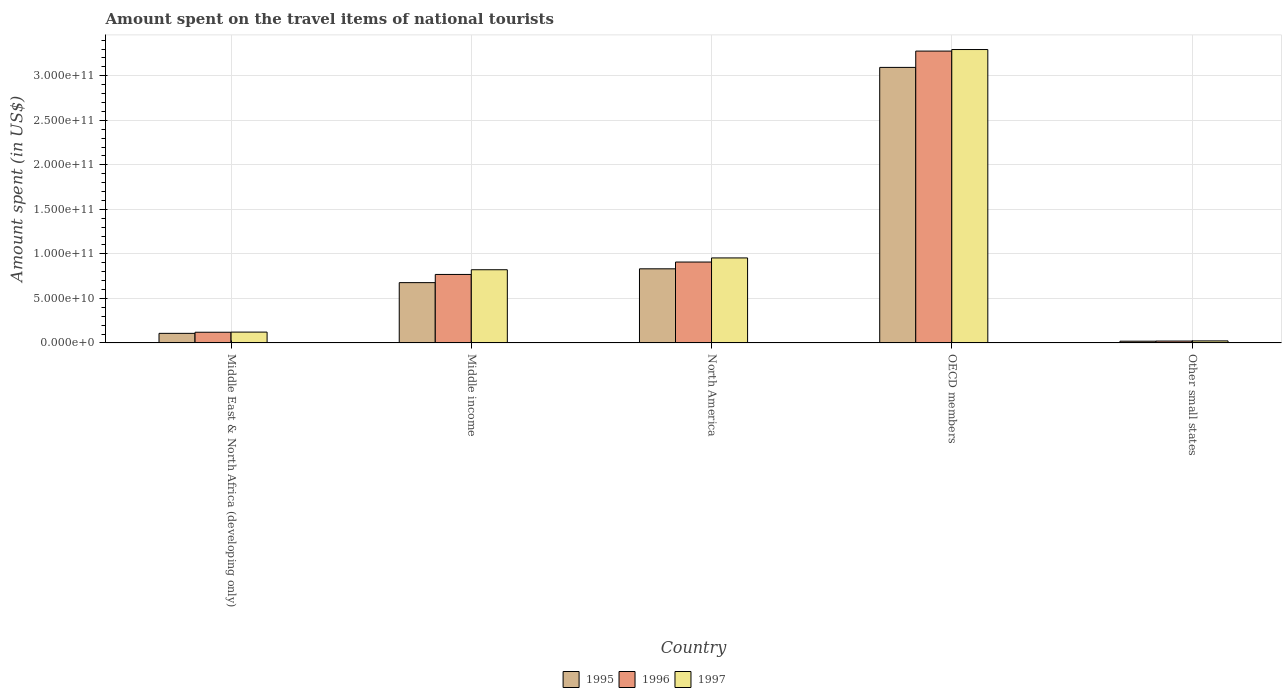Are the number of bars per tick equal to the number of legend labels?
Give a very brief answer. Yes. How many bars are there on the 1st tick from the left?
Provide a succinct answer. 3. What is the label of the 1st group of bars from the left?
Your answer should be compact. Middle East & North Africa (developing only). In how many cases, is the number of bars for a given country not equal to the number of legend labels?
Provide a succinct answer. 0. What is the amount spent on the travel items of national tourists in 1997 in North America?
Make the answer very short. 9.55e+1. Across all countries, what is the maximum amount spent on the travel items of national tourists in 1997?
Your answer should be very brief. 3.29e+11. Across all countries, what is the minimum amount spent on the travel items of national tourists in 1996?
Ensure brevity in your answer.  2.12e+09. In which country was the amount spent on the travel items of national tourists in 1997 minimum?
Keep it short and to the point. Other small states. What is the total amount spent on the travel items of national tourists in 1996 in the graph?
Provide a short and direct response. 5.10e+11. What is the difference between the amount spent on the travel items of national tourists in 1995 in North America and that in OECD members?
Your answer should be very brief. -2.26e+11. What is the difference between the amount spent on the travel items of national tourists in 1995 in OECD members and the amount spent on the travel items of national tourists in 1996 in North America?
Make the answer very short. 2.19e+11. What is the average amount spent on the travel items of national tourists in 1997 per country?
Offer a terse response. 1.04e+11. What is the difference between the amount spent on the travel items of national tourists of/in 1996 and amount spent on the travel items of national tourists of/in 1995 in Other small states?
Provide a succinct answer. 1.64e+08. In how many countries, is the amount spent on the travel items of national tourists in 1995 greater than 170000000000 US$?
Provide a short and direct response. 1. What is the ratio of the amount spent on the travel items of national tourists in 1996 in Middle East & North Africa (developing only) to that in North America?
Offer a terse response. 0.13. Is the amount spent on the travel items of national tourists in 1995 in OECD members less than that in Other small states?
Your answer should be very brief. No. What is the difference between the highest and the second highest amount spent on the travel items of national tourists in 1996?
Your answer should be compact. 2.51e+11. What is the difference between the highest and the lowest amount spent on the travel items of national tourists in 1996?
Your response must be concise. 3.26e+11. In how many countries, is the amount spent on the travel items of national tourists in 1996 greater than the average amount spent on the travel items of national tourists in 1996 taken over all countries?
Your answer should be compact. 1. What does the 2nd bar from the left in OECD members represents?
Offer a very short reply. 1996. How many bars are there?
Keep it short and to the point. 15. How many countries are there in the graph?
Your answer should be very brief. 5. Are the values on the major ticks of Y-axis written in scientific E-notation?
Offer a very short reply. Yes. Does the graph contain any zero values?
Keep it short and to the point. No. Does the graph contain grids?
Give a very brief answer. Yes. Where does the legend appear in the graph?
Ensure brevity in your answer.  Bottom center. How are the legend labels stacked?
Offer a very short reply. Horizontal. What is the title of the graph?
Give a very brief answer. Amount spent on the travel items of national tourists. Does "1992" appear as one of the legend labels in the graph?
Your answer should be compact. No. What is the label or title of the Y-axis?
Your response must be concise. Amount spent (in US$). What is the Amount spent (in US$) of 1995 in Middle East & North Africa (developing only)?
Give a very brief answer. 1.08e+1. What is the Amount spent (in US$) in 1996 in Middle East & North Africa (developing only)?
Make the answer very short. 1.20e+1. What is the Amount spent (in US$) in 1997 in Middle East & North Africa (developing only)?
Your answer should be compact. 1.22e+1. What is the Amount spent (in US$) of 1995 in Middle income?
Offer a very short reply. 6.77e+1. What is the Amount spent (in US$) of 1996 in Middle income?
Make the answer very short. 7.69e+1. What is the Amount spent (in US$) of 1997 in Middle income?
Provide a short and direct response. 8.22e+1. What is the Amount spent (in US$) in 1995 in North America?
Give a very brief answer. 8.32e+1. What is the Amount spent (in US$) of 1996 in North America?
Your answer should be compact. 9.09e+1. What is the Amount spent (in US$) in 1997 in North America?
Offer a terse response. 9.55e+1. What is the Amount spent (in US$) of 1995 in OECD members?
Provide a succinct answer. 3.09e+11. What is the Amount spent (in US$) in 1996 in OECD members?
Keep it short and to the point. 3.28e+11. What is the Amount spent (in US$) in 1997 in OECD members?
Make the answer very short. 3.29e+11. What is the Amount spent (in US$) of 1995 in Other small states?
Keep it short and to the point. 1.95e+09. What is the Amount spent (in US$) in 1996 in Other small states?
Make the answer very short. 2.12e+09. What is the Amount spent (in US$) in 1997 in Other small states?
Your answer should be compact. 2.29e+09. Across all countries, what is the maximum Amount spent (in US$) of 1995?
Keep it short and to the point. 3.09e+11. Across all countries, what is the maximum Amount spent (in US$) in 1996?
Provide a succinct answer. 3.28e+11. Across all countries, what is the maximum Amount spent (in US$) of 1997?
Make the answer very short. 3.29e+11. Across all countries, what is the minimum Amount spent (in US$) in 1995?
Ensure brevity in your answer.  1.95e+09. Across all countries, what is the minimum Amount spent (in US$) in 1996?
Offer a very short reply. 2.12e+09. Across all countries, what is the minimum Amount spent (in US$) in 1997?
Your response must be concise. 2.29e+09. What is the total Amount spent (in US$) of 1995 in the graph?
Your answer should be very brief. 4.73e+11. What is the total Amount spent (in US$) in 1996 in the graph?
Keep it short and to the point. 5.10e+11. What is the total Amount spent (in US$) of 1997 in the graph?
Make the answer very short. 5.22e+11. What is the difference between the Amount spent (in US$) in 1995 in Middle East & North Africa (developing only) and that in Middle income?
Keep it short and to the point. -5.69e+1. What is the difference between the Amount spent (in US$) of 1996 in Middle East & North Africa (developing only) and that in Middle income?
Offer a very short reply. -6.49e+1. What is the difference between the Amount spent (in US$) of 1997 in Middle East & North Africa (developing only) and that in Middle income?
Your answer should be compact. -7.00e+1. What is the difference between the Amount spent (in US$) in 1995 in Middle East & North Africa (developing only) and that in North America?
Your answer should be compact. -7.25e+1. What is the difference between the Amount spent (in US$) of 1996 in Middle East & North Africa (developing only) and that in North America?
Provide a short and direct response. -7.88e+1. What is the difference between the Amount spent (in US$) in 1997 in Middle East & North Africa (developing only) and that in North America?
Make the answer very short. -8.33e+1. What is the difference between the Amount spent (in US$) in 1995 in Middle East & North Africa (developing only) and that in OECD members?
Your answer should be compact. -2.99e+11. What is the difference between the Amount spent (in US$) in 1996 in Middle East & North Africa (developing only) and that in OECD members?
Offer a terse response. -3.16e+11. What is the difference between the Amount spent (in US$) in 1997 in Middle East & North Africa (developing only) and that in OECD members?
Your answer should be very brief. -3.17e+11. What is the difference between the Amount spent (in US$) of 1995 in Middle East & North Africa (developing only) and that in Other small states?
Your answer should be compact. 8.82e+09. What is the difference between the Amount spent (in US$) of 1996 in Middle East & North Africa (developing only) and that in Other small states?
Ensure brevity in your answer.  9.89e+09. What is the difference between the Amount spent (in US$) of 1997 in Middle East & North Africa (developing only) and that in Other small states?
Your response must be concise. 9.88e+09. What is the difference between the Amount spent (in US$) in 1995 in Middle income and that in North America?
Give a very brief answer. -1.55e+1. What is the difference between the Amount spent (in US$) of 1996 in Middle income and that in North America?
Provide a short and direct response. -1.39e+1. What is the difference between the Amount spent (in US$) of 1997 in Middle income and that in North America?
Your answer should be compact. -1.33e+1. What is the difference between the Amount spent (in US$) in 1995 in Middle income and that in OECD members?
Make the answer very short. -2.42e+11. What is the difference between the Amount spent (in US$) of 1996 in Middle income and that in OECD members?
Offer a very short reply. -2.51e+11. What is the difference between the Amount spent (in US$) in 1997 in Middle income and that in OECD members?
Ensure brevity in your answer.  -2.47e+11. What is the difference between the Amount spent (in US$) of 1995 in Middle income and that in Other small states?
Your answer should be compact. 6.58e+1. What is the difference between the Amount spent (in US$) of 1996 in Middle income and that in Other small states?
Make the answer very short. 7.48e+1. What is the difference between the Amount spent (in US$) in 1997 in Middle income and that in Other small states?
Make the answer very short. 7.99e+1. What is the difference between the Amount spent (in US$) in 1995 in North America and that in OECD members?
Keep it short and to the point. -2.26e+11. What is the difference between the Amount spent (in US$) in 1996 in North America and that in OECD members?
Keep it short and to the point. -2.37e+11. What is the difference between the Amount spent (in US$) in 1997 in North America and that in OECD members?
Your answer should be compact. -2.34e+11. What is the difference between the Amount spent (in US$) of 1995 in North America and that in Other small states?
Your answer should be compact. 8.13e+1. What is the difference between the Amount spent (in US$) of 1996 in North America and that in Other small states?
Keep it short and to the point. 8.87e+1. What is the difference between the Amount spent (in US$) in 1997 in North America and that in Other small states?
Keep it short and to the point. 9.32e+1. What is the difference between the Amount spent (in US$) of 1995 in OECD members and that in Other small states?
Keep it short and to the point. 3.07e+11. What is the difference between the Amount spent (in US$) in 1996 in OECD members and that in Other small states?
Give a very brief answer. 3.26e+11. What is the difference between the Amount spent (in US$) in 1997 in OECD members and that in Other small states?
Your response must be concise. 3.27e+11. What is the difference between the Amount spent (in US$) of 1995 in Middle East & North Africa (developing only) and the Amount spent (in US$) of 1996 in Middle income?
Your answer should be compact. -6.61e+1. What is the difference between the Amount spent (in US$) in 1995 in Middle East & North Africa (developing only) and the Amount spent (in US$) in 1997 in Middle income?
Your answer should be compact. -7.14e+1. What is the difference between the Amount spent (in US$) of 1996 in Middle East & North Africa (developing only) and the Amount spent (in US$) of 1997 in Middle income?
Provide a succinct answer. -7.02e+1. What is the difference between the Amount spent (in US$) in 1995 in Middle East & North Africa (developing only) and the Amount spent (in US$) in 1996 in North America?
Your answer should be very brief. -8.01e+1. What is the difference between the Amount spent (in US$) in 1995 in Middle East & North Africa (developing only) and the Amount spent (in US$) in 1997 in North America?
Offer a terse response. -8.47e+1. What is the difference between the Amount spent (in US$) of 1996 in Middle East & North Africa (developing only) and the Amount spent (in US$) of 1997 in North America?
Give a very brief answer. -8.35e+1. What is the difference between the Amount spent (in US$) in 1995 in Middle East & North Africa (developing only) and the Amount spent (in US$) in 1996 in OECD members?
Keep it short and to the point. -3.17e+11. What is the difference between the Amount spent (in US$) of 1995 in Middle East & North Africa (developing only) and the Amount spent (in US$) of 1997 in OECD members?
Keep it short and to the point. -3.19e+11. What is the difference between the Amount spent (in US$) in 1996 in Middle East & North Africa (developing only) and the Amount spent (in US$) in 1997 in OECD members?
Your answer should be very brief. -3.17e+11. What is the difference between the Amount spent (in US$) of 1995 in Middle East & North Africa (developing only) and the Amount spent (in US$) of 1996 in Other small states?
Make the answer very short. 8.65e+09. What is the difference between the Amount spent (in US$) in 1995 in Middle East & North Africa (developing only) and the Amount spent (in US$) in 1997 in Other small states?
Provide a succinct answer. 8.48e+09. What is the difference between the Amount spent (in US$) of 1996 in Middle East & North Africa (developing only) and the Amount spent (in US$) of 1997 in Other small states?
Provide a succinct answer. 9.72e+09. What is the difference between the Amount spent (in US$) of 1995 in Middle income and the Amount spent (in US$) of 1996 in North America?
Keep it short and to the point. -2.31e+1. What is the difference between the Amount spent (in US$) of 1995 in Middle income and the Amount spent (in US$) of 1997 in North America?
Make the answer very short. -2.78e+1. What is the difference between the Amount spent (in US$) in 1996 in Middle income and the Amount spent (in US$) in 1997 in North America?
Your answer should be very brief. -1.86e+1. What is the difference between the Amount spent (in US$) of 1995 in Middle income and the Amount spent (in US$) of 1996 in OECD members?
Keep it short and to the point. -2.60e+11. What is the difference between the Amount spent (in US$) in 1995 in Middle income and the Amount spent (in US$) in 1997 in OECD members?
Make the answer very short. -2.62e+11. What is the difference between the Amount spent (in US$) of 1996 in Middle income and the Amount spent (in US$) of 1997 in OECD members?
Your response must be concise. -2.53e+11. What is the difference between the Amount spent (in US$) in 1995 in Middle income and the Amount spent (in US$) in 1996 in Other small states?
Provide a succinct answer. 6.56e+1. What is the difference between the Amount spent (in US$) of 1995 in Middle income and the Amount spent (in US$) of 1997 in Other small states?
Your answer should be compact. 6.54e+1. What is the difference between the Amount spent (in US$) of 1996 in Middle income and the Amount spent (in US$) of 1997 in Other small states?
Provide a succinct answer. 7.46e+1. What is the difference between the Amount spent (in US$) in 1995 in North America and the Amount spent (in US$) in 1996 in OECD members?
Your answer should be very brief. -2.45e+11. What is the difference between the Amount spent (in US$) of 1995 in North America and the Amount spent (in US$) of 1997 in OECD members?
Your answer should be compact. -2.46e+11. What is the difference between the Amount spent (in US$) of 1996 in North America and the Amount spent (in US$) of 1997 in OECD members?
Your response must be concise. -2.39e+11. What is the difference between the Amount spent (in US$) in 1995 in North America and the Amount spent (in US$) in 1996 in Other small states?
Keep it short and to the point. 8.11e+1. What is the difference between the Amount spent (in US$) in 1995 in North America and the Amount spent (in US$) in 1997 in Other small states?
Provide a short and direct response. 8.10e+1. What is the difference between the Amount spent (in US$) of 1996 in North America and the Amount spent (in US$) of 1997 in Other small states?
Give a very brief answer. 8.86e+1. What is the difference between the Amount spent (in US$) of 1995 in OECD members and the Amount spent (in US$) of 1996 in Other small states?
Make the answer very short. 3.07e+11. What is the difference between the Amount spent (in US$) of 1995 in OECD members and the Amount spent (in US$) of 1997 in Other small states?
Make the answer very short. 3.07e+11. What is the difference between the Amount spent (in US$) of 1996 in OECD members and the Amount spent (in US$) of 1997 in Other small states?
Give a very brief answer. 3.25e+11. What is the average Amount spent (in US$) in 1995 per country?
Your response must be concise. 9.46e+1. What is the average Amount spent (in US$) of 1996 per country?
Ensure brevity in your answer.  1.02e+11. What is the average Amount spent (in US$) in 1997 per country?
Your response must be concise. 1.04e+11. What is the difference between the Amount spent (in US$) of 1995 and Amount spent (in US$) of 1996 in Middle East & North Africa (developing only)?
Make the answer very short. -1.24e+09. What is the difference between the Amount spent (in US$) in 1995 and Amount spent (in US$) in 1997 in Middle East & North Africa (developing only)?
Offer a very short reply. -1.40e+09. What is the difference between the Amount spent (in US$) in 1996 and Amount spent (in US$) in 1997 in Middle East & North Africa (developing only)?
Your response must be concise. -1.61e+08. What is the difference between the Amount spent (in US$) of 1995 and Amount spent (in US$) of 1996 in Middle income?
Your answer should be very brief. -9.19e+09. What is the difference between the Amount spent (in US$) in 1995 and Amount spent (in US$) in 1997 in Middle income?
Your answer should be very brief. -1.45e+1. What is the difference between the Amount spent (in US$) in 1996 and Amount spent (in US$) in 1997 in Middle income?
Keep it short and to the point. -5.28e+09. What is the difference between the Amount spent (in US$) of 1995 and Amount spent (in US$) of 1996 in North America?
Keep it short and to the point. -7.61e+09. What is the difference between the Amount spent (in US$) in 1995 and Amount spent (in US$) in 1997 in North America?
Your response must be concise. -1.22e+1. What is the difference between the Amount spent (in US$) in 1996 and Amount spent (in US$) in 1997 in North America?
Your response must be concise. -4.62e+09. What is the difference between the Amount spent (in US$) in 1995 and Amount spent (in US$) in 1996 in OECD members?
Make the answer very short. -1.83e+1. What is the difference between the Amount spent (in US$) of 1995 and Amount spent (in US$) of 1997 in OECD members?
Your answer should be compact. -2.01e+1. What is the difference between the Amount spent (in US$) of 1996 and Amount spent (in US$) of 1997 in OECD members?
Provide a short and direct response. -1.72e+09. What is the difference between the Amount spent (in US$) in 1995 and Amount spent (in US$) in 1996 in Other small states?
Offer a very short reply. -1.64e+08. What is the difference between the Amount spent (in US$) in 1995 and Amount spent (in US$) in 1997 in Other small states?
Provide a succinct answer. -3.34e+08. What is the difference between the Amount spent (in US$) of 1996 and Amount spent (in US$) of 1997 in Other small states?
Make the answer very short. -1.69e+08. What is the ratio of the Amount spent (in US$) in 1995 in Middle East & North Africa (developing only) to that in Middle income?
Your answer should be very brief. 0.16. What is the ratio of the Amount spent (in US$) in 1996 in Middle East & North Africa (developing only) to that in Middle income?
Your response must be concise. 0.16. What is the ratio of the Amount spent (in US$) in 1997 in Middle East & North Africa (developing only) to that in Middle income?
Your answer should be compact. 0.15. What is the ratio of the Amount spent (in US$) in 1995 in Middle East & North Africa (developing only) to that in North America?
Make the answer very short. 0.13. What is the ratio of the Amount spent (in US$) of 1996 in Middle East & North Africa (developing only) to that in North America?
Offer a very short reply. 0.13. What is the ratio of the Amount spent (in US$) of 1997 in Middle East & North Africa (developing only) to that in North America?
Keep it short and to the point. 0.13. What is the ratio of the Amount spent (in US$) in 1995 in Middle East & North Africa (developing only) to that in OECD members?
Provide a succinct answer. 0.03. What is the ratio of the Amount spent (in US$) in 1996 in Middle East & North Africa (developing only) to that in OECD members?
Ensure brevity in your answer.  0.04. What is the ratio of the Amount spent (in US$) in 1997 in Middle East & North Africa (developing only) to that in OECD members?
Make the answer very short. 0.04. What is the ratio of the Amount spent (in US$) of 1995 in Middle East & North Africa (developing only) to that in Other small states?
Provide a short and direct response. 5.51. What is the ratio of the Amount spent (in US$) in 1996 in Middle East & North Africa (developing only) to that in Other small states?
Provide a short and direct response. 5.67. What is the ratio of the Amount spent (in US$) of 1997 in Middle East & North Africa (developing only) to that in Other small states?
Make the answer very short. 5.32. What is the ratio of the Amount spent (in US$) in 1995 in Middle income to that in North America?
Give a very brief answer. 0.81. What is the ratio of the Amount spent (in US$) in 1996 in Middle income to that in North America?
Offer a terse response. 0.85. What is the ratio of the Amount spent (in US$) in 1997 in Middle income to that in North America?
Make the answer very short. 0.86. What is the ratio of the Amount spent (in US$) of 1995 in Middle income to that in OECD members?
Offer a very short reply. 0.22. What is the ratio of the Amount spent (in US$) of 1996 in Middle income to that in OECD members?
Provide a succinct answer. 0.23. What is the ratio of the Amount spent (in US$) of 1997 in Middle income to that in OECD members?
Ensure brevity in your answer.  0.25. What is the ratio of the Amount spent (in US$) of 1995 in Middle income to that in Other small states?
Give a very brief answer. 34.66. What is the ratio of the Amount spent (in US$) of 1996 in Middle income to that in Other small states?
Offer a terse response. 36.31. What is the ratio of the Amount spent (in US$) of 1997 in Middle income to that in Other small states?
Your answer should be very brief. 35.93. What is the ratio of the Amount spent (in US$) in 1995 in North America to that in OECD members?
Make the answer very short. 0.27. What is the ratio of the Amount spent (in US$) in 1996 in North America to that in OECD members?
Your response must be concise. 0.28. What is the ratio of the Amount spent (in US$) in 1997 in North America to that in OECD members?
Provide a succinct answer. 0.29. What is the ratio of the Amount spent (in US$) in 1995 in North America to that in Other small states?
Provide a succinct answer. 42.6. What is the ratio of the Amount spent (in US$) of 1996 in North America to that in Other small states?
Your answer should be very brief. 42.89. What is the ratio of the Amount spent (in US$) in 1997 in North America to that in Other small states?
Your answer should be very brief. 41.73. What is the ratio of the Amount spent (in US$) in 1995 in OECD members to that in Other small states?
Keep it short and to the point. 158.36. What is the ratio of the Amount spent (in US$) in 1996 in OECD members to that in Other small states?
Your answer should be compact. 154.72. What is the ratio of the Amount spent (in US$) of 1997 in OECD members to that in Other small states?
Ensure brevity in your answer.  144.02. What is the difference between the highest and the second highest Amount spent (in US$) of 1995?
Offer a very short reply. 2.26e+11. What is the difference between the highest and the second highest Amount spent (in US$) of 1996?
Give a very brief answer. 2.37e+11. What is the difference between the highest and the second highest Amount spent (in US$) in 1997?
Your response must be concise. 2.34e+11. What is the difference between the highest and the lowest Amount spent (in US$) in 1995?
Give a very brief answer. 3.07e+11. What is the difference between the highest and the lowest Amount spent (in US$) of 1996?
Provide a short and direct response. 3.26e+11. What is the difference between the highest and the lowest Amount spent (in US$) of 1997?
Ensure brevity in your answer.  3.27e+11. 